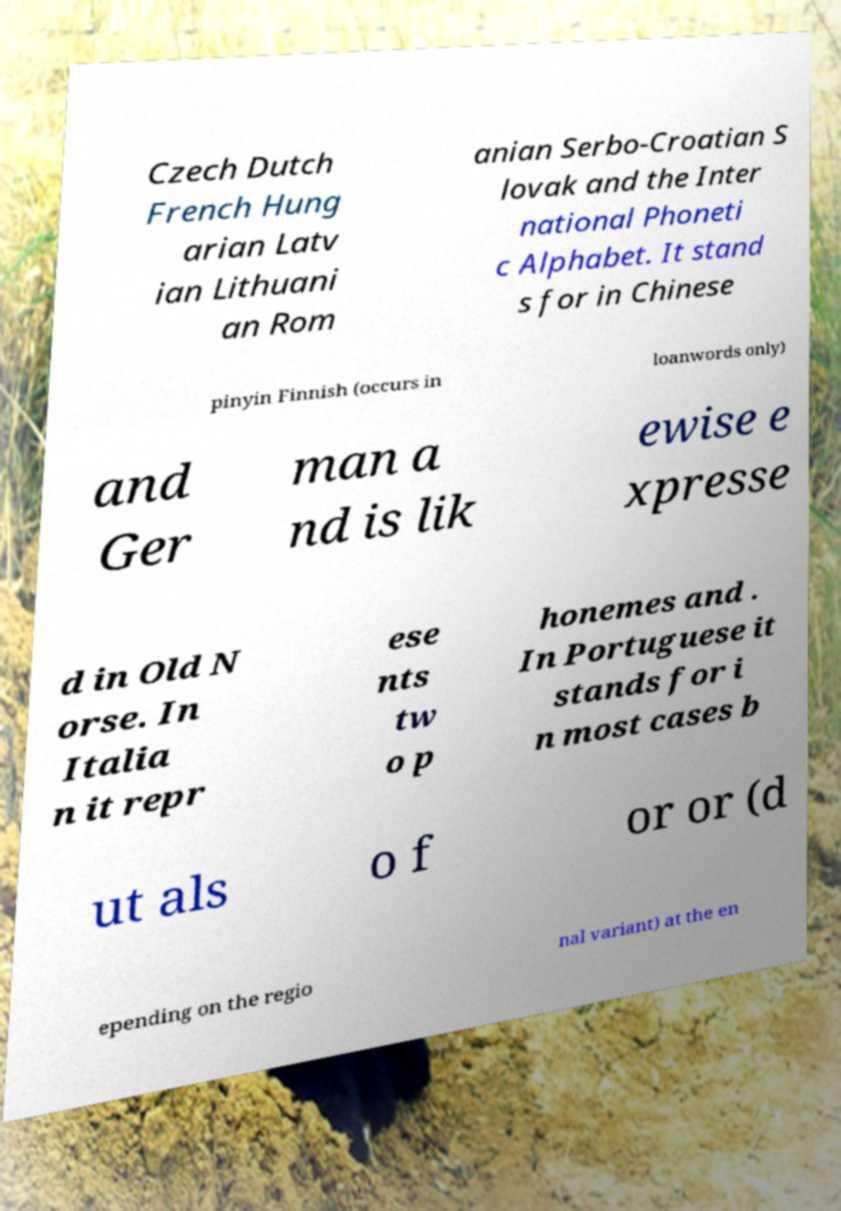Can you accurately transcribe the text from the provided image for me? Czech Dutch French Hung arian Latv ian Lithuani an Rom anian Serbo-Croatian S lovak and the Inter national Phoneti c Alphabet. It stand s for in Chinese pinyin Finnish (occurs in loanwords only) and Ger man a nd is lik ewise e xpresse d in Old N orse. In Italia n it repr ese nts tw o p honemes and . In Portuguese it stands for i n most cases b ut als o f or or (d epending on the regio nal variant) at the en 